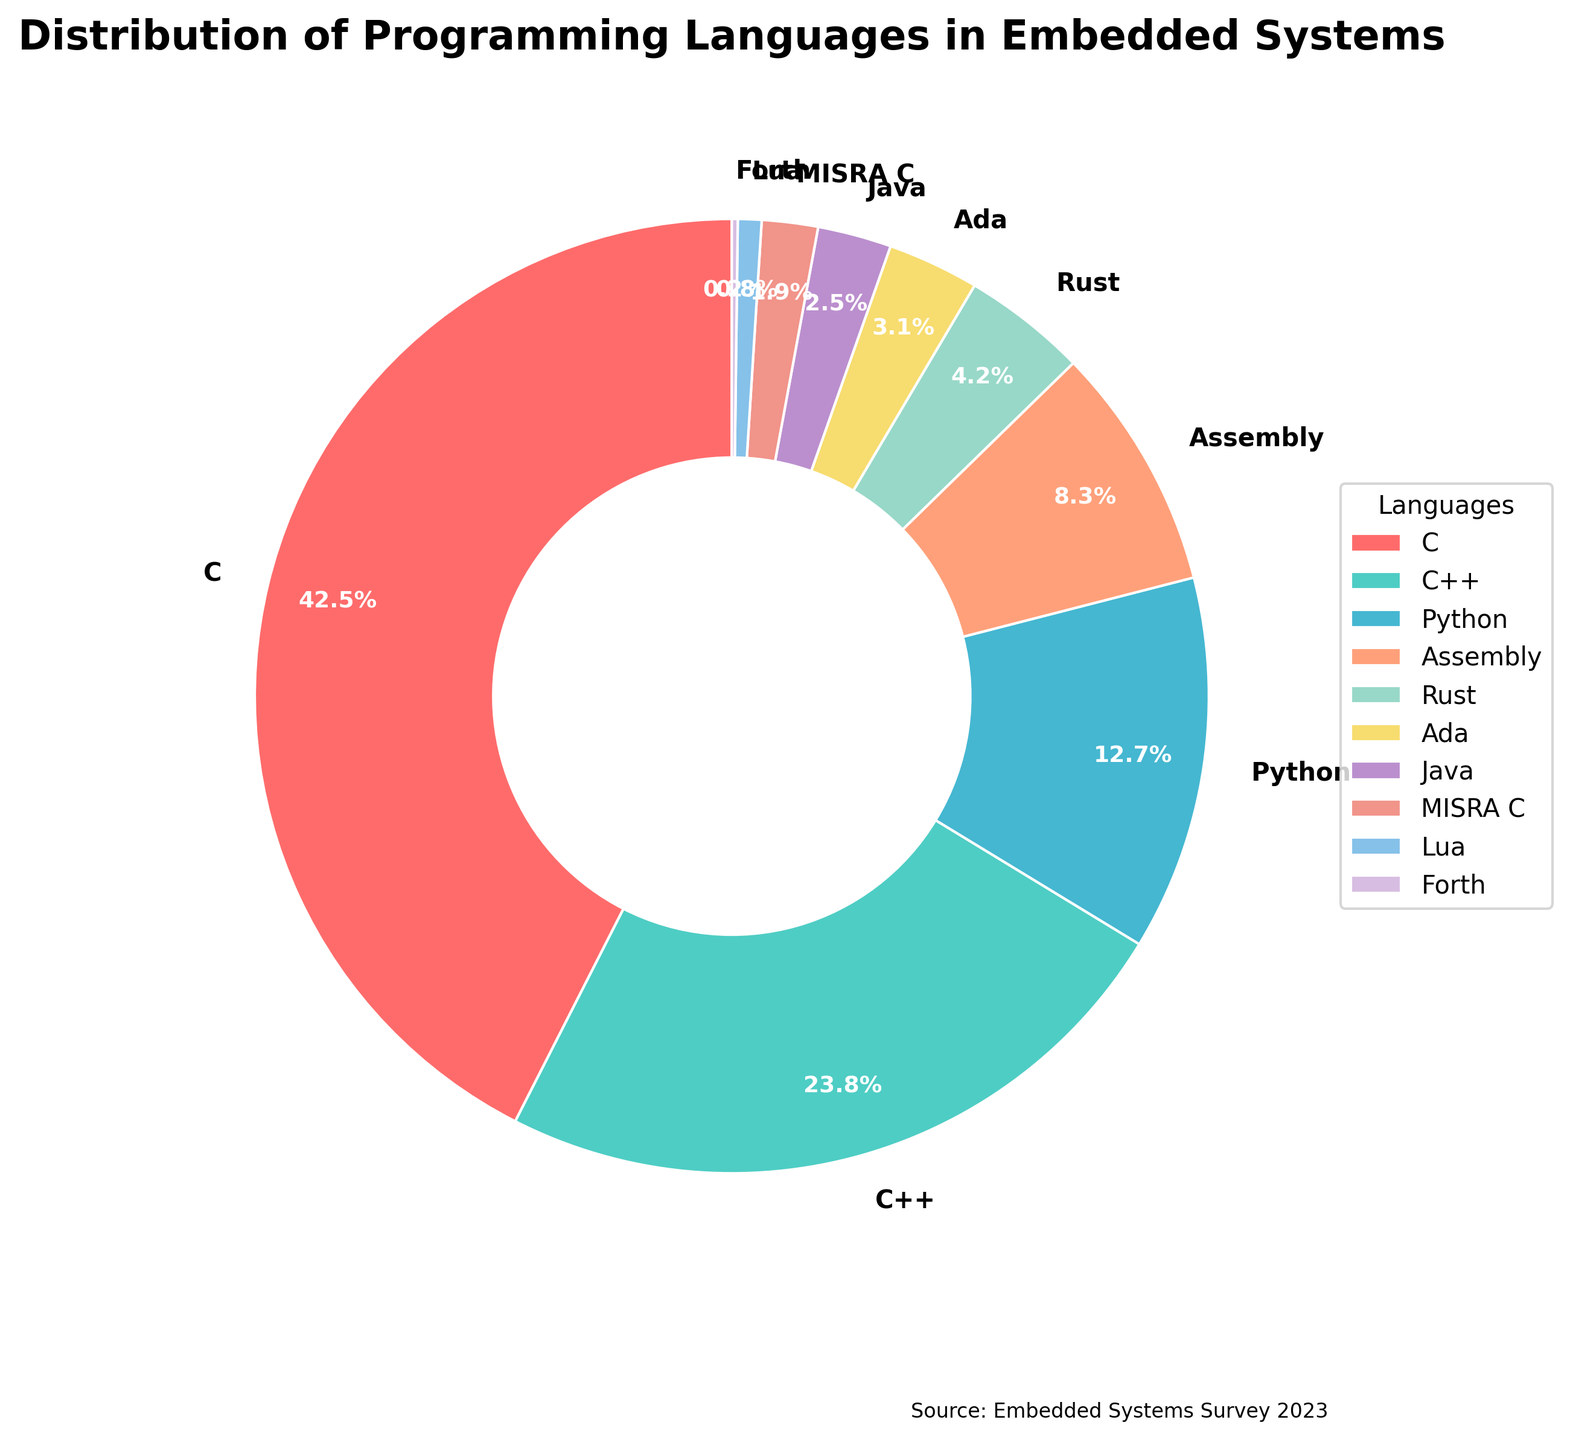Which programming language has the highest usage in embedded systems? The figure shows a pie chart with percentages for each programming language. The largest slice represents C with 42.5%.
Answer: C What is the combined percentage usage of Assembly and Ada in embedded systems? To find the combined percentage, add the percentages of Assembly and Ada from the pie chart. Assembly has 8.3% and Ada has 3.1%. So, 8.3% + 3.1% = 11.4%.
Answer: 11.4% How does the usage of Python compare to that of Java in embedded systems? From the pie chart, Python has a percentage of 12.7% and Java has 2.5%. Since 12.7% is significantly greater than 2.5%, Python is used more than Java.
Answer: Python is used more Which language has the smallest slice, indicating the least usage in embedded systems? The pie chart shows multiple languages with varying percentages. The smallest slice corresponds to Forth with 0.2%.
Answer: Forth What is the total percentage of the top three most used programming languages in embedded systems? Identify the top three most used languages from the pie chart. These are C (42.5%), C++ (23.8%), and Python (12.7%). Sum these percentages: 42.5% + 23.8% + 12.7% = 79%.
Answer: 79% Which two languages together account for approximately one-third of the total usage? To find two languages that sum to about one-third (≈33.33%), look for slices summing to around this value. Rust (4.2%) and Python (12.7%) together contribute to (4.2% + 12.7% =) 16.9%, which is close but not sufficient. Instead, consider two larger slices: C++ (23.8%) and Assembly (8.3%), together they make (23.8% + 8.3% =) 32.1%, which is close to one-third.
Answer: C++ and Assembly If you were to group languages with less than 5% usage into a single category, what would their combined percentage be? Identify all languages with less than 5% usage from the pie chart: Rust (4.2%), Ada (3.1%), Java (2.5%), MISRA C (1.9%), Lua (0.8%), Forth (0.2%). Summing these percentages: 4.2% + 3.1% + 2.5% + 1.9% + 0.8% + 0.2% = 12.7%.
Answer: 12.7% 